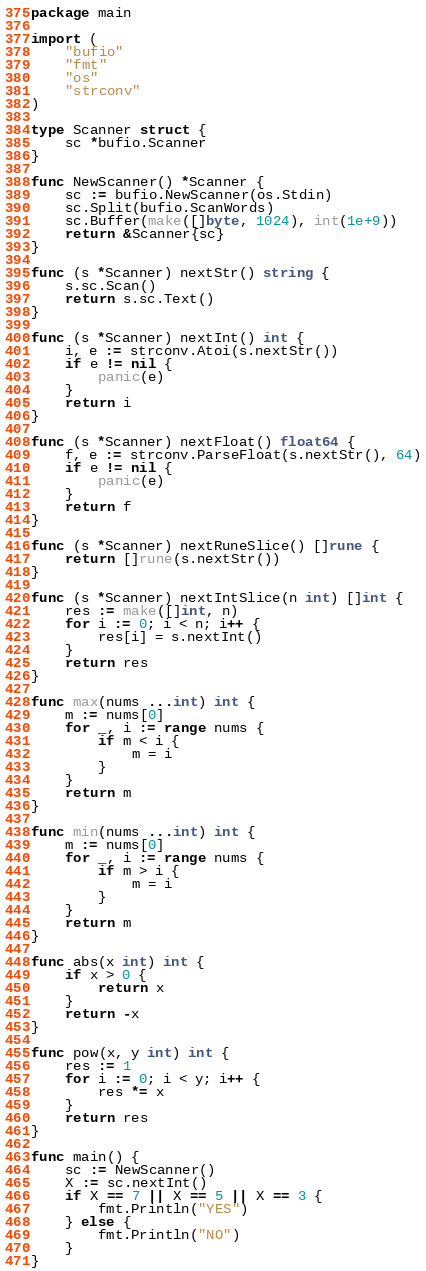<code> <loc_0><loc_0><loc_500><loc_500><_Go_>package main

import (
	"bufio"
	"fmt"
	"os"
	"strconv"
)

type Scanner struct {
	sc *bufio.Scanner
}

func NewScanner() *Scanner {
	sc := bufio.NewScanner(os.Stdin)
	sc.Split(bufio.ScanWords)
	sc.Buffer(make([]byte, 1024), int(1e+9))
	return &Scanner{sc}
}

func (s *Scanner) nextStr() string {
	s.sc.Scan()
	return s.sc.Text()
}

func (s *Scanner) nextInt() int {
	i, e := strconv.Atoi(s.nextStr())
	if e != nil {
		panic(e)
	}
	return i
}

func (s *Scanner) nextFloat() float64 {
	f, e := strconv.ParseFloat(s.nextStr(), 64)
	if e != nil {
		panic(e)
	}
	return f
}

func (s *Scanner) nextRuneSlice() []rune {
	return []rune(s.nextStr())
}

func (s *Scanner) nextIntSlice(n int) []int {
	res := make([]int, n)
	for i := 0; i < n; i++ {
		res[i] = s.nextInt()
	}
	return res
}

func max(nums ...int) int {
	m := nums[0]
	for _, i := range nums {
		if m < i {
			m = i
		}
	}
	return m
}

func min(nums ...int) int {
	m := nums[0]
	for _, i := range nums {
		if m > i {
			m = i
		}
	}
	return m
}

func abs(x int) int {
	if x > 0 {
		return x
	}
	return -x
}

func pow(x, y int) int {
	res := 1
	for i := 0; i < y; i++ {
		res *= x
	}
	return res
}

func main() {
	sc := NewScanner()
	X := sc.nextInt()
	if X == 7 || X == 5 || X == 3 {
		fmt.Println("YES")
	} else {
		fmt.Println("NO")
	}
}
</code> 